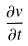<formula> <loc_0><loc_0><loc_500><loc_500>\frac { \partial v } { \partial t }</formula> 